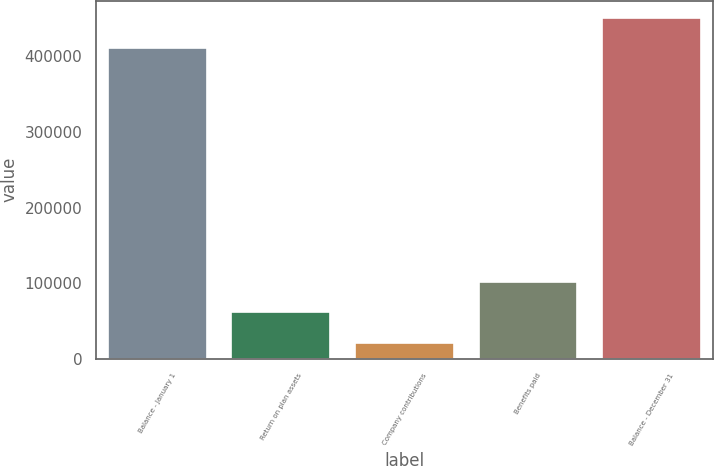<chart> <loc_0><loc_0><loc_500><loc_500><bar_chart><fcel>Balance - January 1<fcel>Return on plan assets<fcel>Company contributions<fcel>Benefits paid<fcel>Balance - December 31<nl><fcel>410462<fcel>61349.8<fcel>20746<fcel>101954<fcel>451066<nl></chart> 